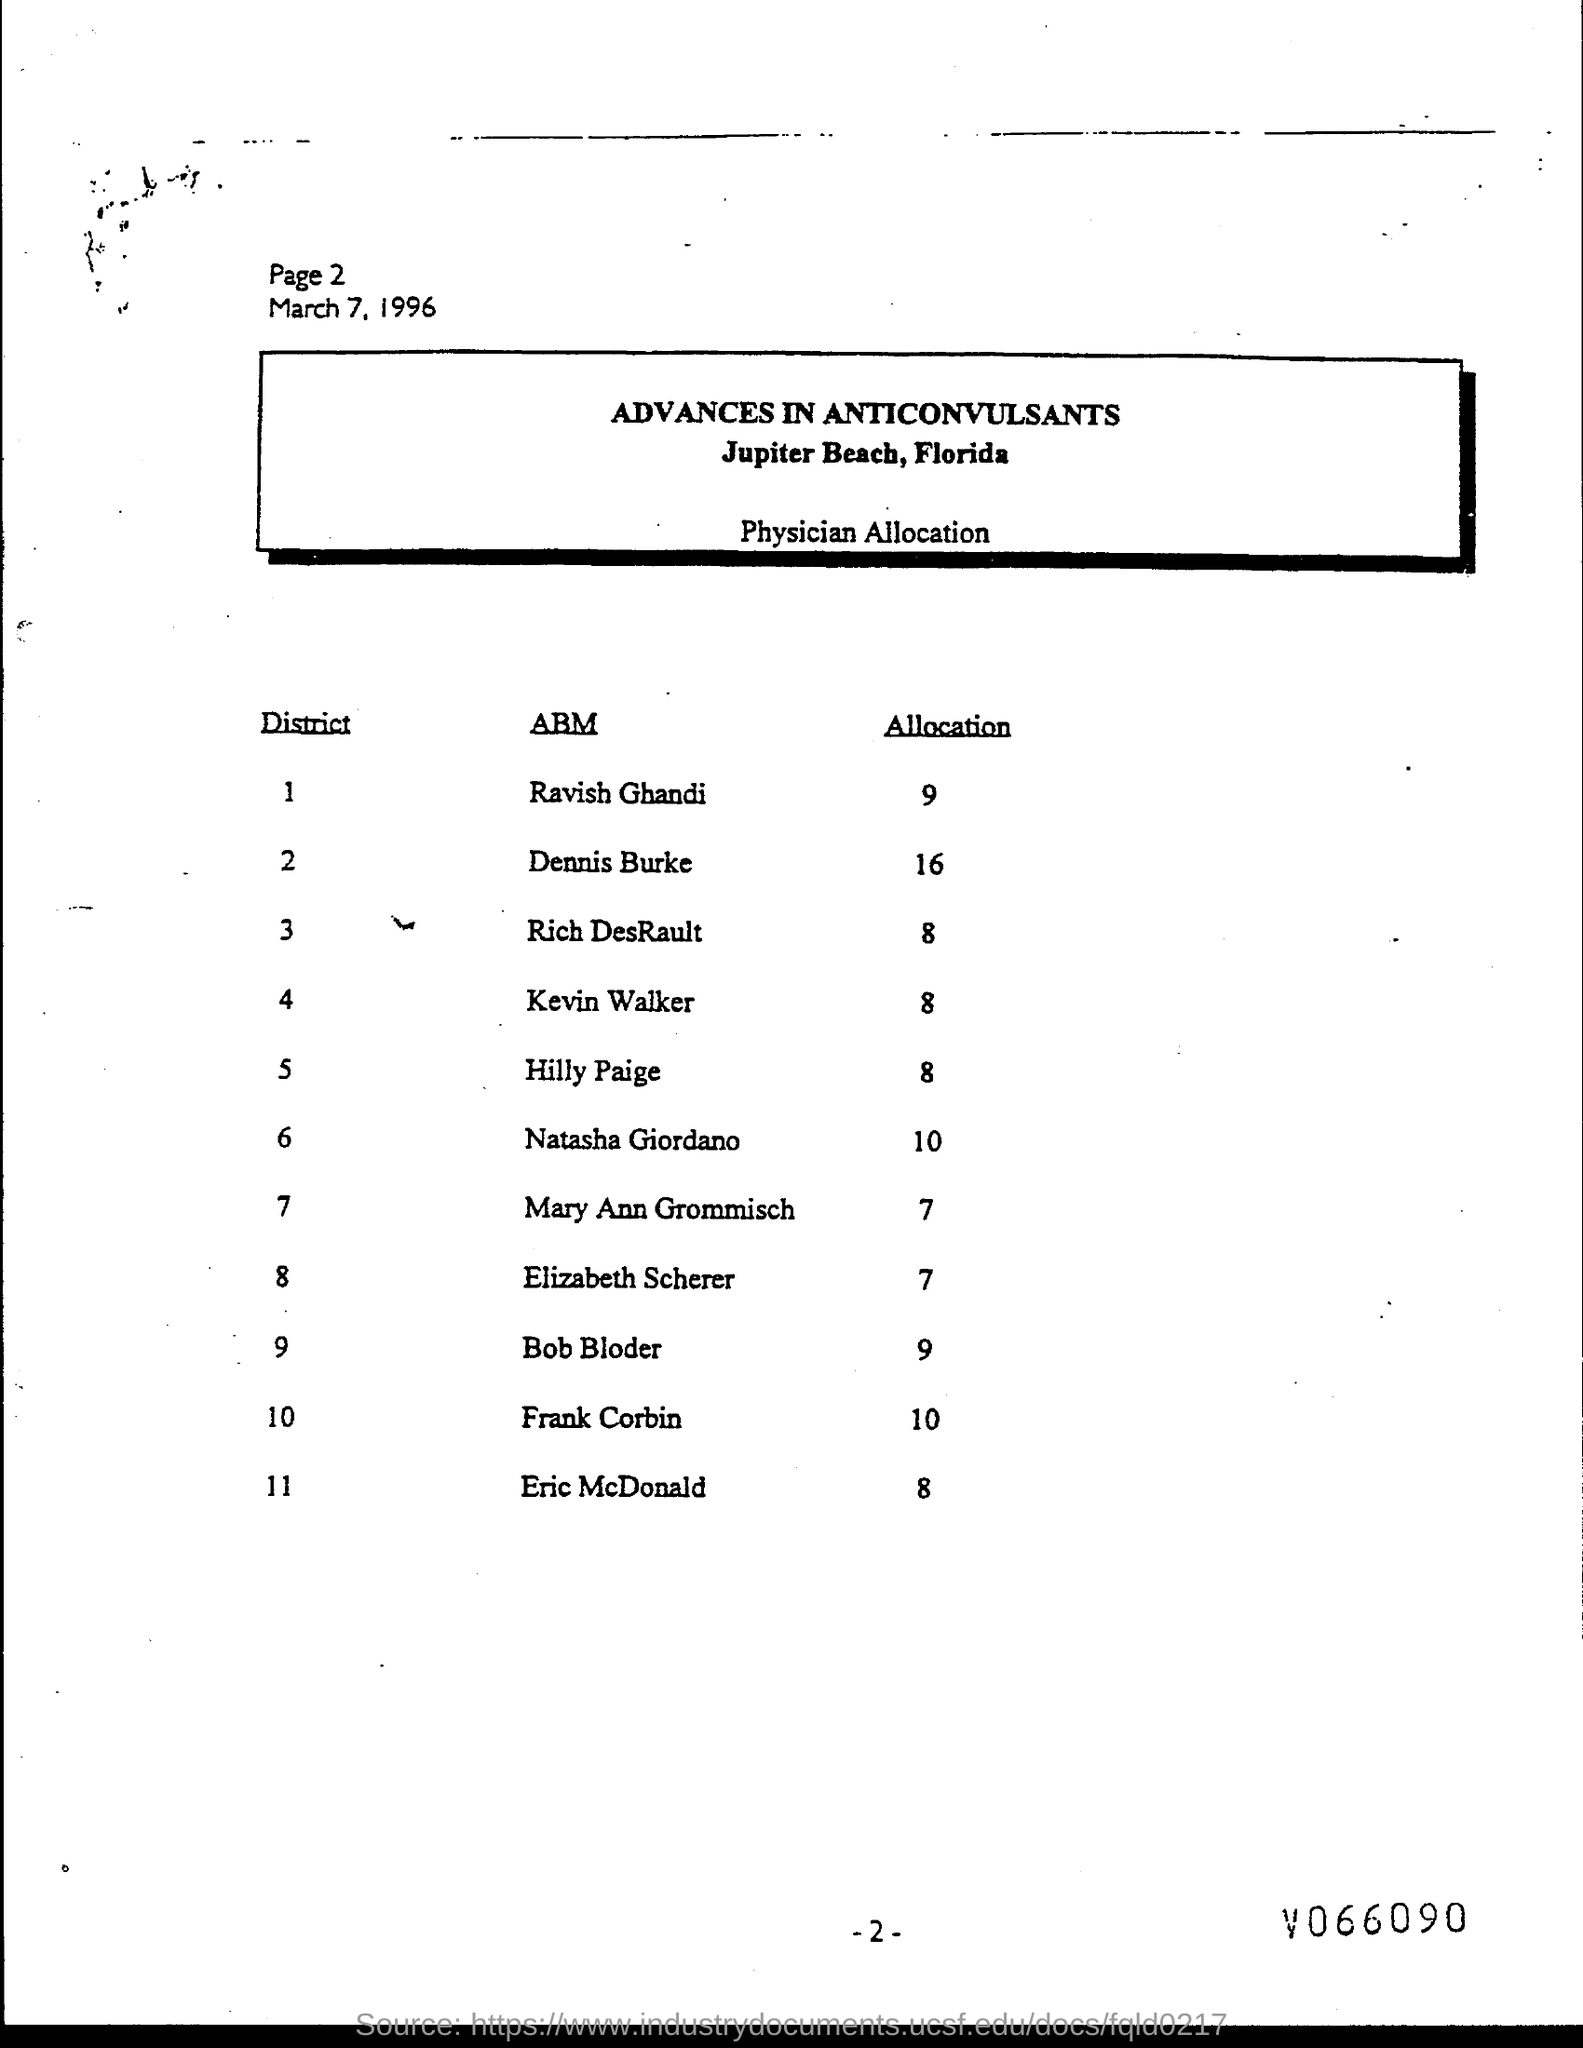List a handful of essential elements in this visual. The allocation for Ravish Gandhi is 9. Natasha Giordano's allocation is 10.. The page number at the top of the page is 2, as declared. What are allocations for Bob Bloder?" is a question asking for an explanation or clarification. What are allocations for Rich DesRault? Eight people. 